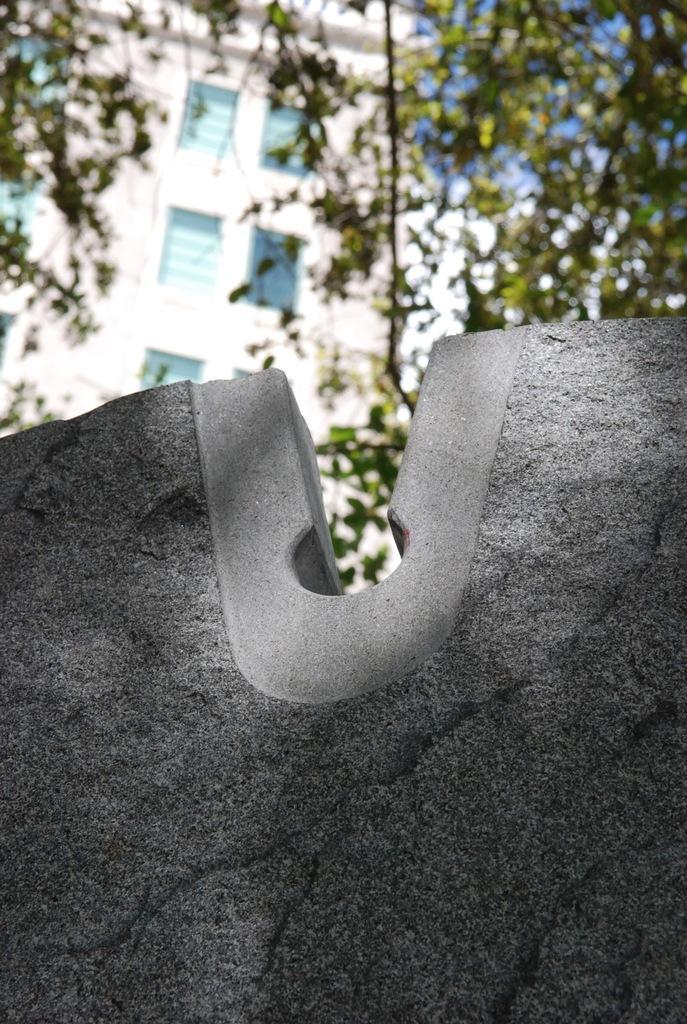How would you summarize this image in a sentence or two? In this picture I can see the rock, behind there are some buildings and trees. 